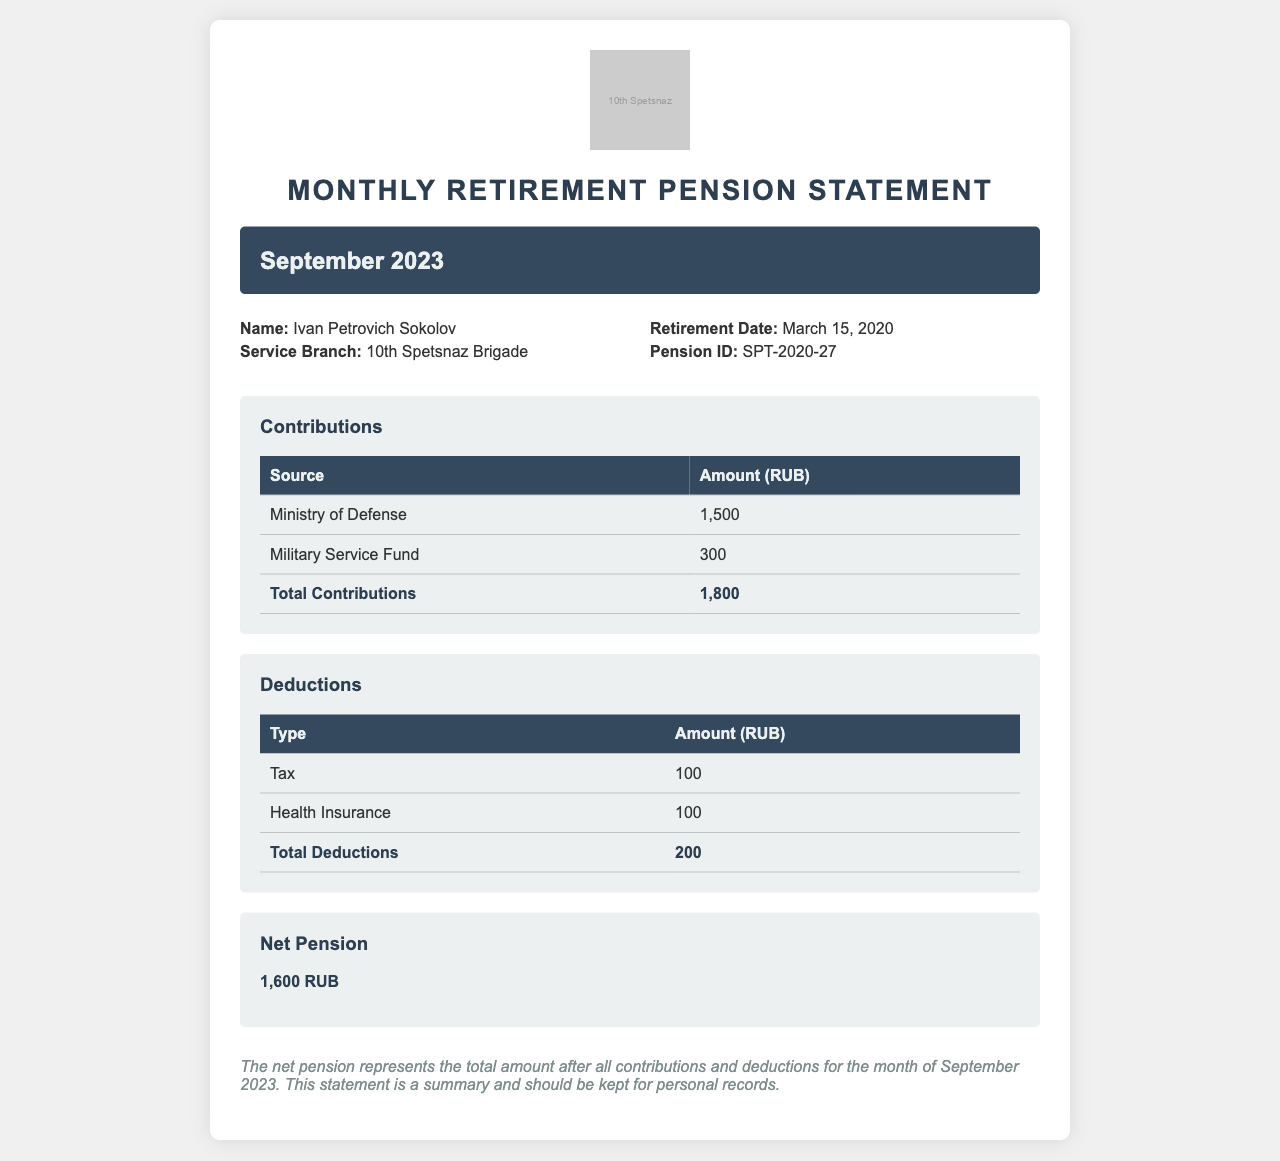What is the pension ID? The pension ID is a unique identifier listed in the document under personal details.
Answer: SPT-2020-27 What is the total amount of contributions? The total contributions are found in the contributions section, which sums the amounts listed.
Answer: 1,800 What type of health insurance deduction is noted? The document lists 'Health Insurance' as a type of deduction.
Answer: Health Insurance What is the net pension amount for September 2023? The net pension is calculated after deductions and is stated in the net pension section.
Answer: 1,600 RUB Who is the recipient of this pension statement? The recipient's name is identified at the beginning of the statement.
Answer: Ivan Petrovich Sokolov What is the total amount of deductions? The total deductions are detailed in the deductions section of the document.
Answer: 200 What branch of service is associated with this pension? The service branch is provided in the personal details of the statement.
Answer: 10th Spetsnaz Brigade What is the retirement date listed? The retirement date is specified under personal details as the day the individual retired.
Answer: March 15, 2020 What message is included in the notes section? The notes section typically contains a summary or advisory message about the statement.
Answer: This statement is a summary and should be kept for personal records 